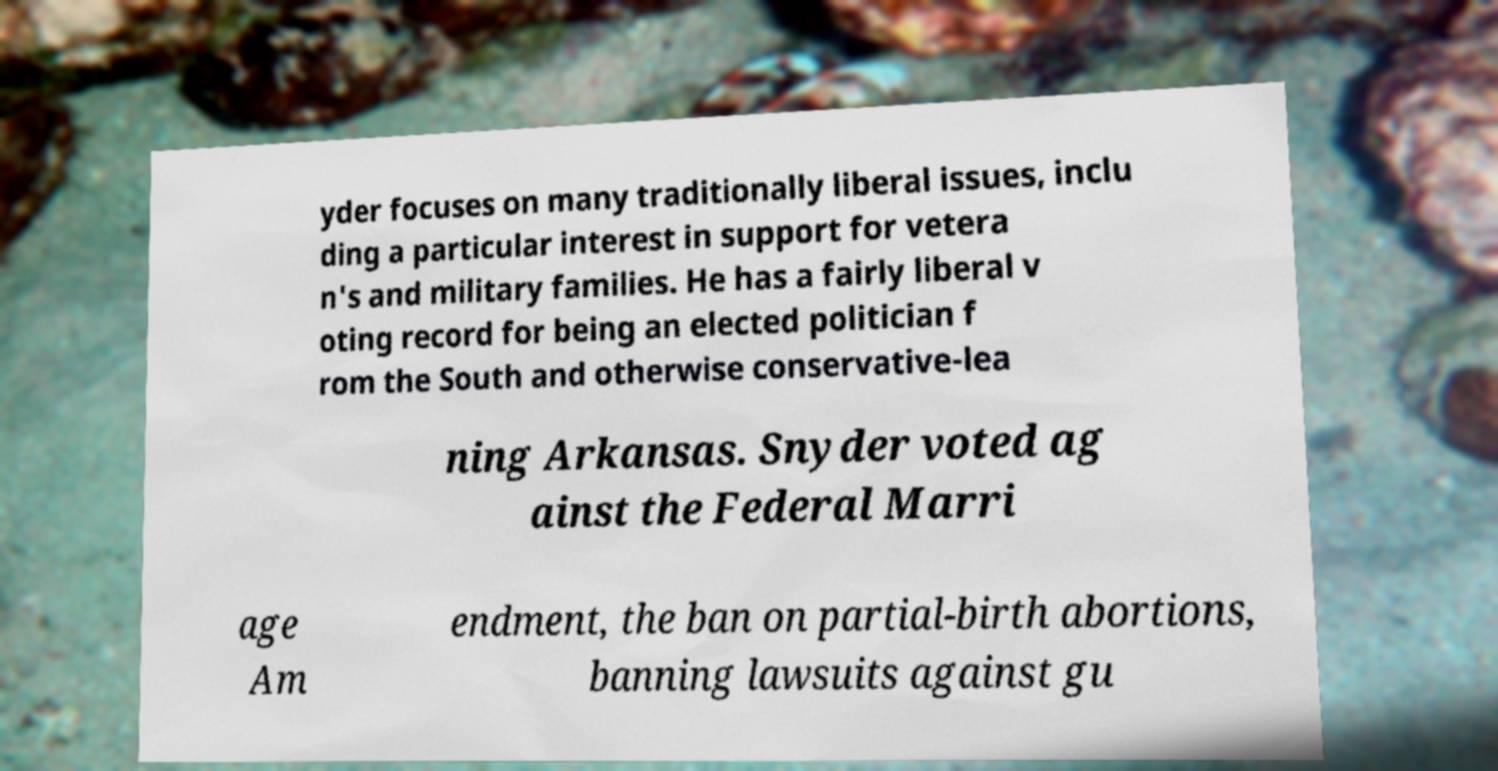Could you assist in decoding the text presented in this image and type it out clearly? yder focuses on many traditionally liberal issues, inclu ding a particular interest in support for vetera n's and military families. He has a fairly liberal v oting record for being an elected politician f rom the South and otherwise conservative-lea ning Arkansas. Snyder voted ag ainst the Federal Marri age Am endment, the ban on partial-birth abortions, banning lawsuits against gu 